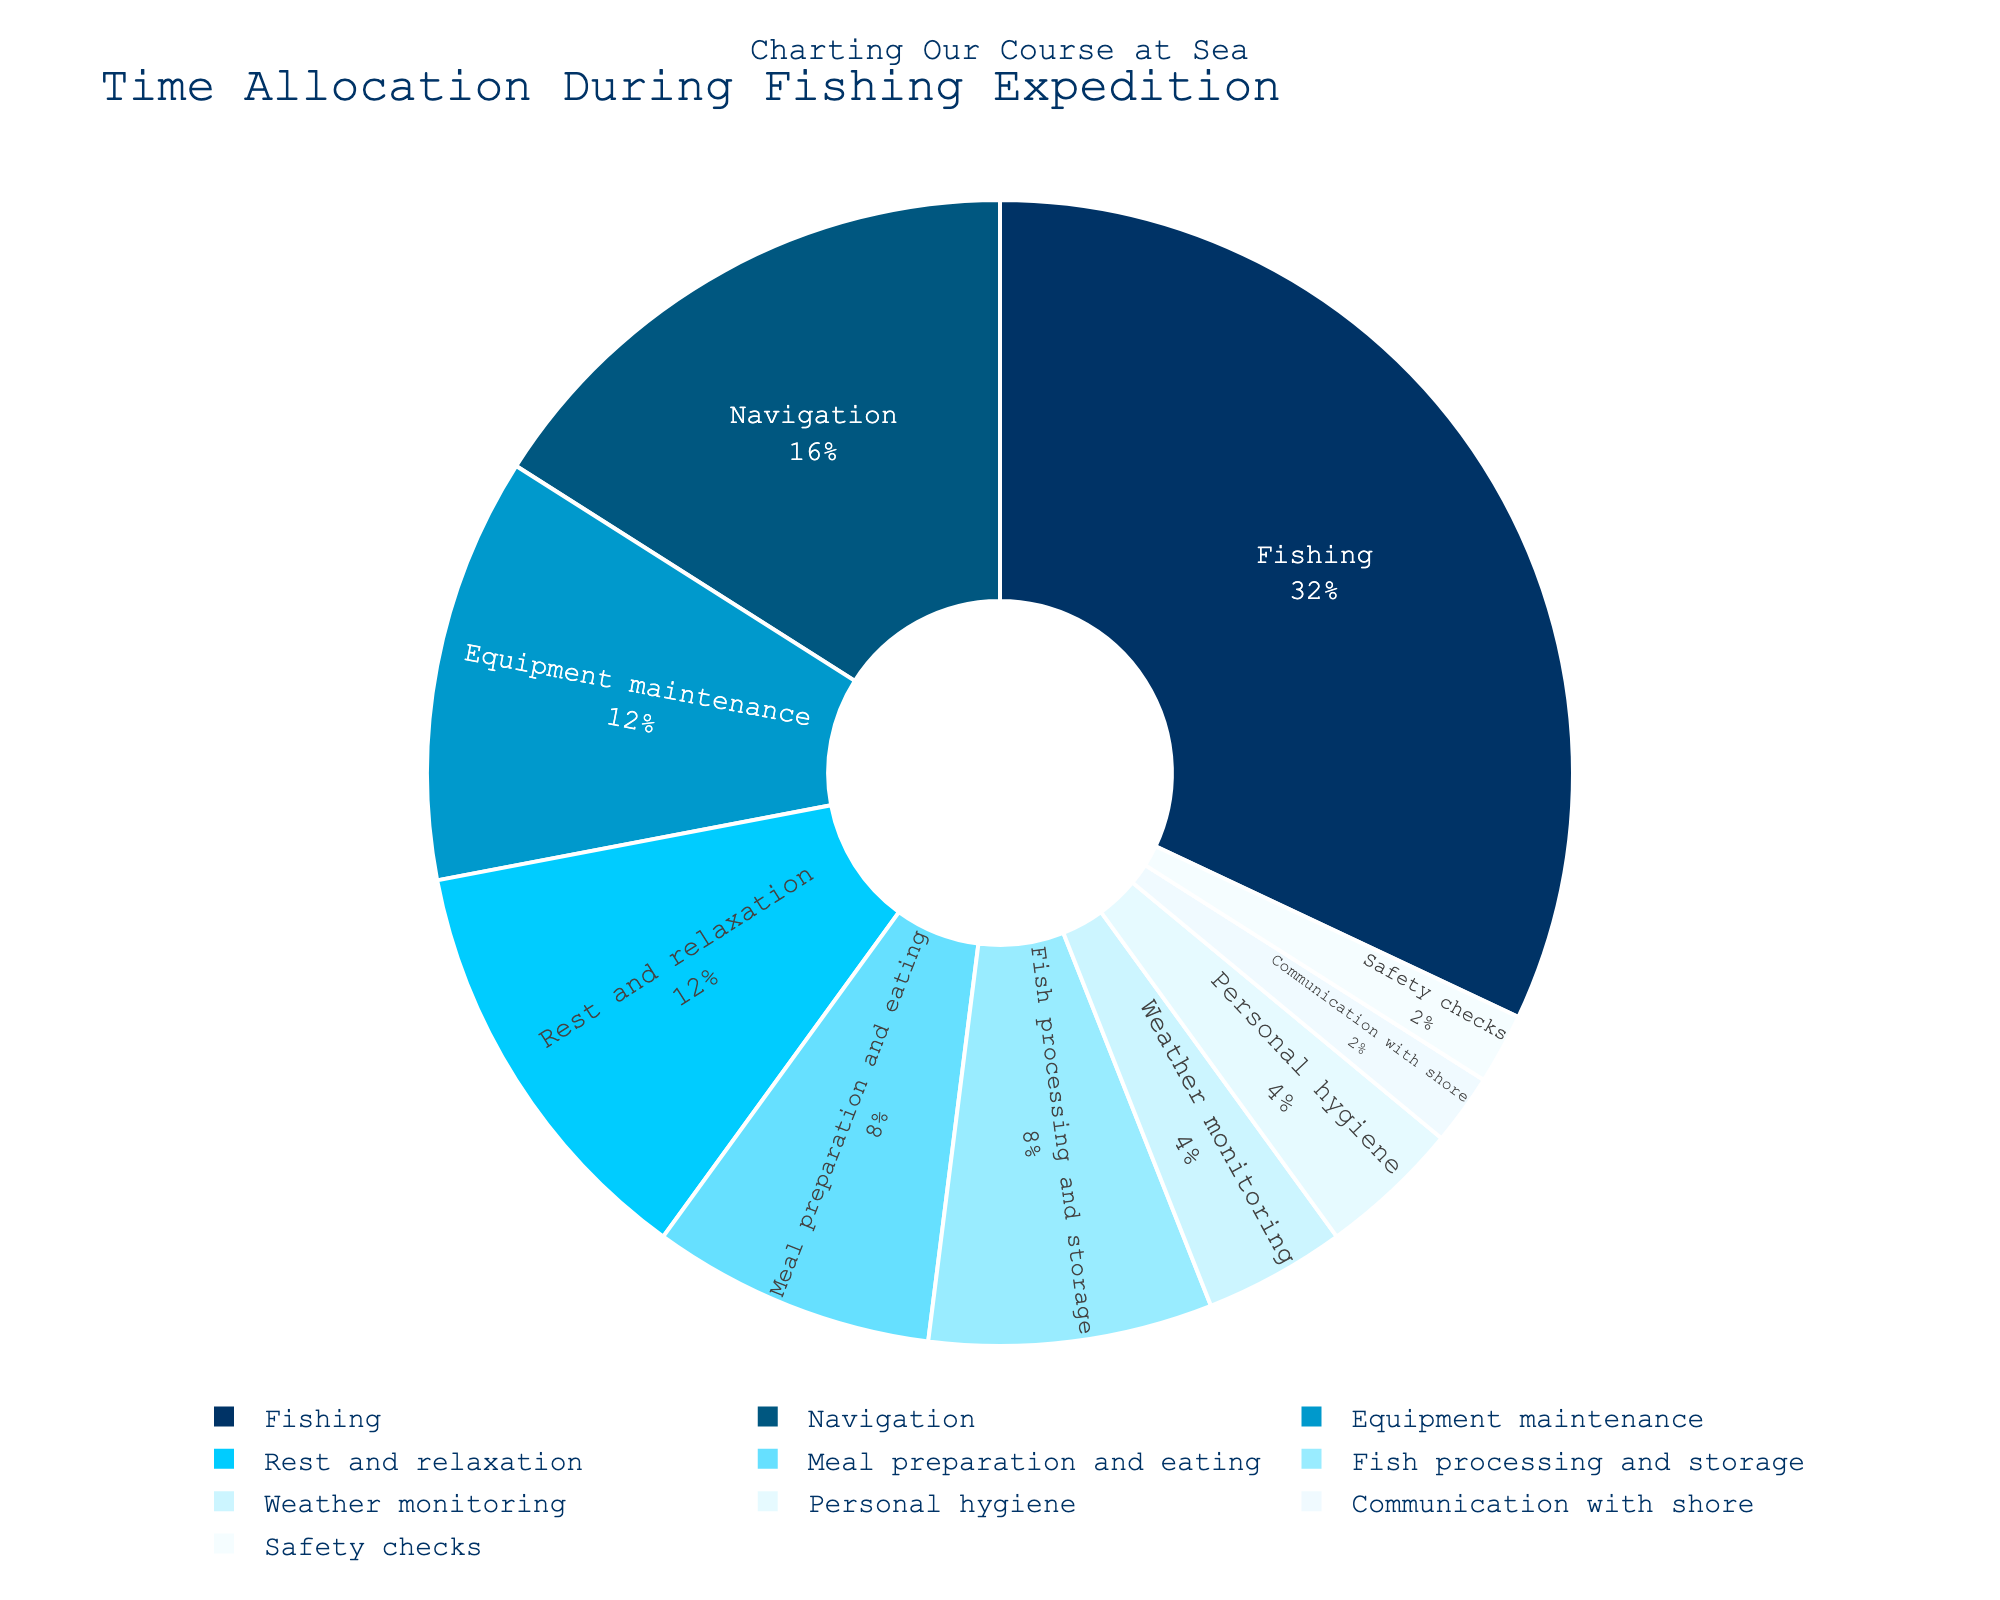What activity takes up the most time during the fishing expedition? The largest segment in the pie chart is labeled "Fishing," and it represents 8 hours, which is the highest amount of time allocated compared to other activities.
Answer: Fishing How much time is dedicated to rest and relaxation compared to weather monitoring? The pie chart shows rest and relaxation take up 3 hours, while weather monitoring takes 1 hour. The comparison of these two times is a difference of 3 - 1 = 2 hours.
Answer: 2 hours What is the total time spent on meal preparation, eating, and personal hygiene combined? The pie chart indicates that 2 hours are spent on meal preparation and eating, and 1 hour on personal hygiene. Adding these together gives 2 + 1 = 3 hours.
Answer: 3 hours How does the time spent on safety checks compare to communication with shore? Safety checks and communication with shore both share equal slices in the pie chart, each accounting for 0.5 hours.
Answer: Equal What color represents the activity of 'Navigation'? According to the color palette depicted in the pie chart, Navigation is represented by a shade of blue, specifically the second color in the sequence: '#005780'.
Answer: Blue Which activity takes up the least amount of time in the fishing expedition? The smallest slices in the pie chart are those of "Safety checks" and "Communication with shore," both taking 0.5 hours.
Answer: Safety checks and Communication with shore What is the combined time spent on equipment maintenance, fish processing, and weather monitoring? Equipment maintenance is allocated 3 hours, fish processing 2 hours, and weather monitoring 1 hour. So, the combined time spent on these activities is 3 + 2 + 1 = 6 hours.
Answer: 6 hours How does the time spent on fishing compare to the time spent on any other single activity? Fishing, represented by the largest segment, takes up 8 hours. All other activities take fewer hours individually, with Navigation being the second highest at 4 hours. Thus, fishing occupies more time than any other single activity.
Answer: More What is the percentage of total time devoted to fishing? Fishing occupies 8 out of the total 25 hours (8 + 4 + 3 + 2 + 3 + 1 + 2 + 0.5 + 0.5 + 1). To find the percentage: (8 / 25) * 100% = 32%.
Answer: 32% What time is allocated to rest and relaxation plus equipment maintenance, and how does this compare to the time spent on fishing? Rest and relaxation takes 3 hours and equipment maintenance takes 3 hours as well. Adding these gives 3 + 3 = 6 hours. When compared with fishing, which takes 8 hours, the combined time spent on rest and equipment is less by 8 - 6 = 2 hours.
Answer: 2 hours less 